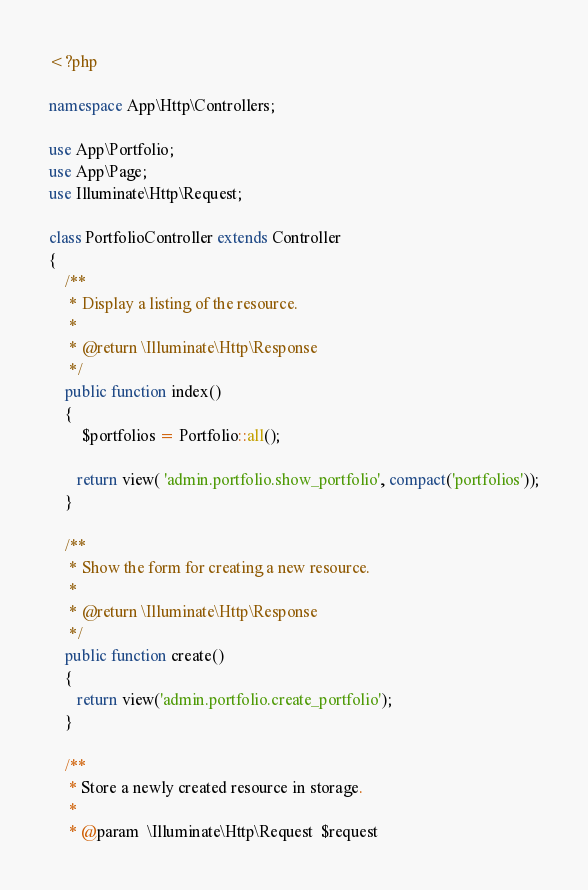Convert code to text. <code><loc_0><loc_0><loc_500><loc_500><_PHP_><?php

namespace App\Http\Controllers;

use App\Portfolio;
use App\Page;
use Illuminate\Http\Request;

class PortfolioController extends Controller
{
    /**
     * Display a listing of the resource.
     *
     * @return \Illuminate\Http\Response
     */
    public function index()
    {
        $portfolios = Portfolio::all();

       return view( 'admin.portfolio.show_portfolio', compact('portfolios'));
    }

    /**
     * Show the form for creating a new resource.
     *
     * @return \Illuminate\Http\Response
     */
    public function create()
    {
       return view('admin.portfolio.create_portfolio'); 
    }

    /**
     * Store a newly created resource in storage.
     *
     * @param  \Illuminate\Http\Request  $request</code> 